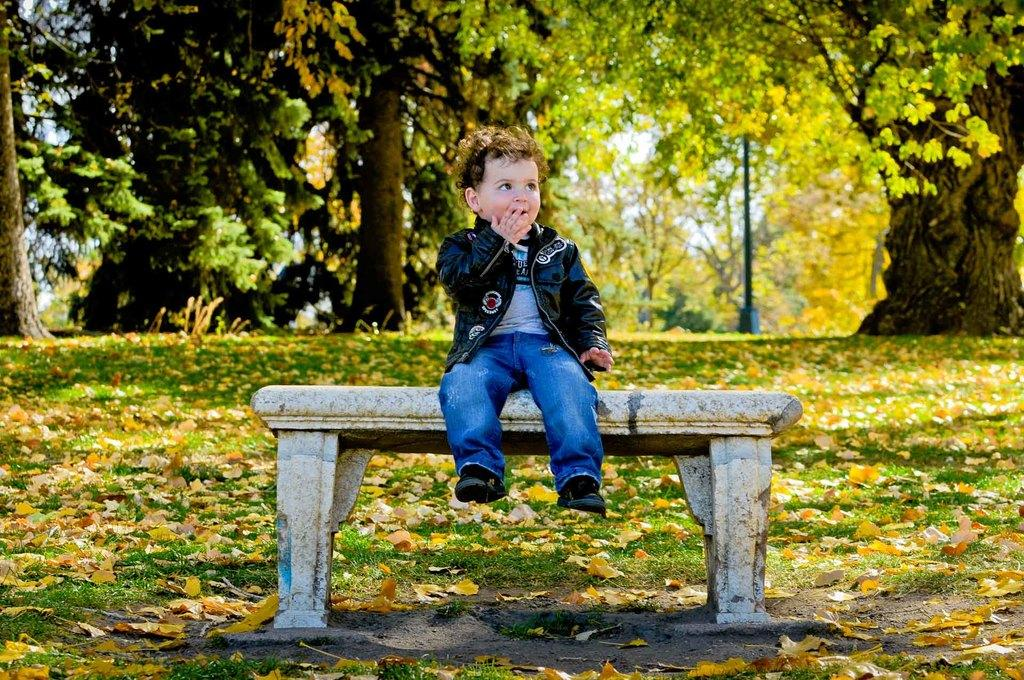Who is the main subject in the image? There is a boy in the image. What is the boy doing in the image? The boy is sitting on a bench. What can be seen in the background of the image? There are trees, a pole, and the sky visible in the background of the image. What type of sofa is in the image? There is no sofa present in the image. What time of day is it in the image? The time of day is not mentioned in the image, so it cannot be determined. 